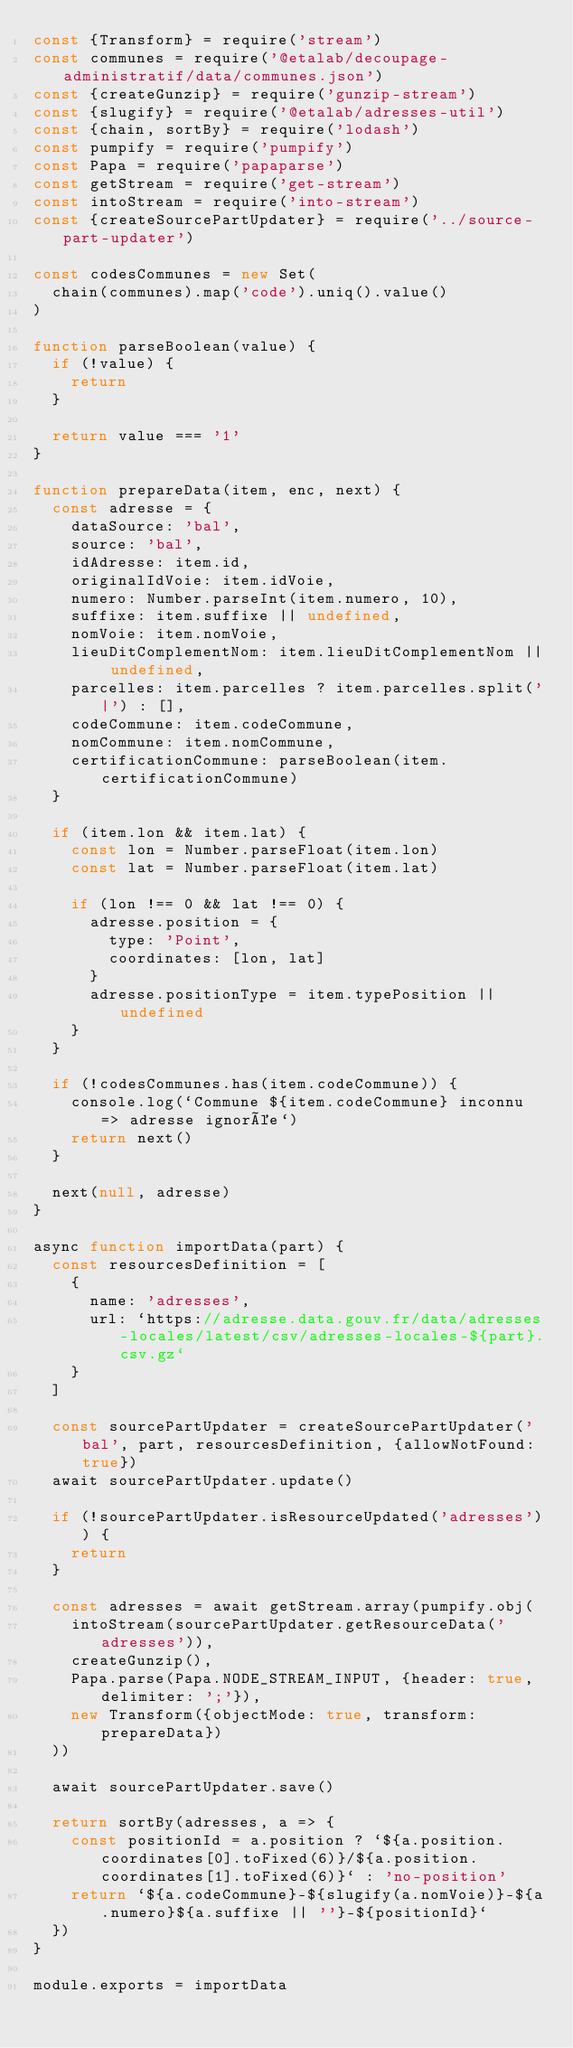Convert code to text. <code><loc_0><loc_0><loc_500><loc_500><_JavaScript_>const {Transform} = require('stream')
const communes = require('@etalab/decoupage-administratif/data/communes.json')
const {createGunzip} = require('gunzip-stream')
const {slugify} = require('@etalab/adresses-util')
const {chain, sortBy} = require('lodash')
const pumpify = require('pumpify')
const Papa = require('papaparse')
const getStream = require('get-stream')
const intoStream = require('into-stream')
const {createSourcePartUpdater} = require('../source-part-updater')

const codesCommunes = new Set(
  chain(communes).map('code').uniq().value()
)

function parseBoolean(value) {
  if (!value) {
    return
  }

  return value === '1'
}

function prepareData(item, enc, next) {
  const adresse = {
    dataSource: 'bal',
    source: 'bal',
    idAdresse: item.id,
    originalIdVoie: item.idVoie,
    numero: Number.parseInt(item.numero, 10),
    suffixe: item.suffixe || undefined,
    nomVoie: item.nomVoie,
    lieuDitComplementNom: item.lieuDitComplementNom || undefined,
    parcelles: item.parcelles ? item.parcelles.split('|') : [],
    codeCommune: item.codeCommune,
    nomCommune: item.nomCommune,
    certificationCommune: parseBoolean(item.certificationCommune)
  }

  if (item.lon && item.lat) {
    const lon = Number.parseFloat(item.lon)
    const lat = Number.parseFloat(item.lat)

    if (lon !== 0 && lat !== 0) {
      adresse.position = {
        type: 'Point',
        coordinates: [lon, lat]
      }
      adresse.positionType = item.typePosition || undefined
    }
  }

  if (!codesCommunes.has(item.codeCommune)) {
    console.log(`Commune ${item.codeCommune} inconnu => adresse ignorée`)
    return next()
  }

  next(null, adresse)
}

async function importData(part) {
  const resourcesDefinition = [
    {
      name: 'adresses',
      url: `https://adresse.data.gouv.fr/data/adresses-locales/latest/csv/adresses-locales-${part}.csv.gz`
    }
  ]

  const sourcePartUpdater = createSourcePartUpdater('bal', part, resourcesDefinition, {allowNotFound: true})
  await sourcePartUpdater.update()

  if (!sourcePartUpdater.isResourceUpdated('adresses')) {
    return
  }

  const adresses = await getStream.array(pumpify.obj(
    intoStream(sourcePartUpdater.getResourceData('adresses')),
    createGunzip(),
    Papa.parse(Papa.NODE_STREAM_INPUT, {header: true, delimiter: ';'}),
    new Transform({objectMode: true, transform: prepareData})
  ))

  await sourcePartUpdater.save()

  return sortBy(adresses, a => {
    const positionId = a.position ? `${a.position.coordinates[0].toFixed(6)}/${a.position.coordinates[1].toFixed(6)}` : 'no-position'
    return `${a.codeCommune}-${slugify(a.nomVoie)}-${a.numero}${a.suffixe || ''}-${positionId}`
  })
}

module.exports = importData
</code> 